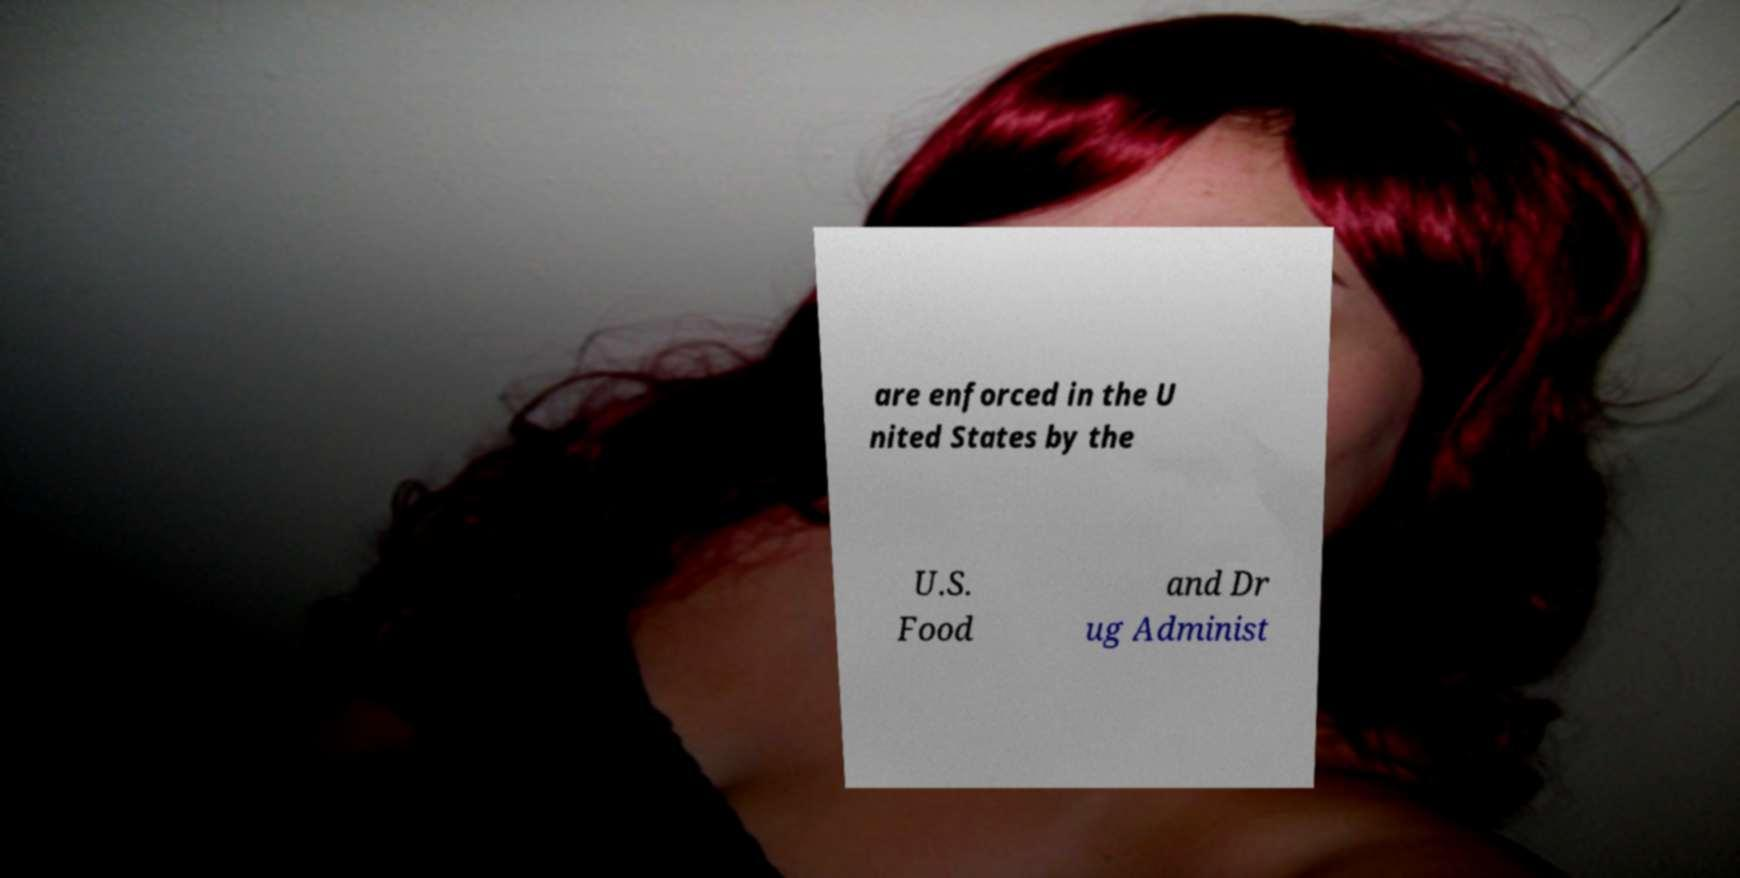Can you read and provide the text displayed in the image?This photo seems to have some interesting text. Can you extract and type it out for me? are enforced in the U nited States by the U.S. Food and Dr ug Administ 